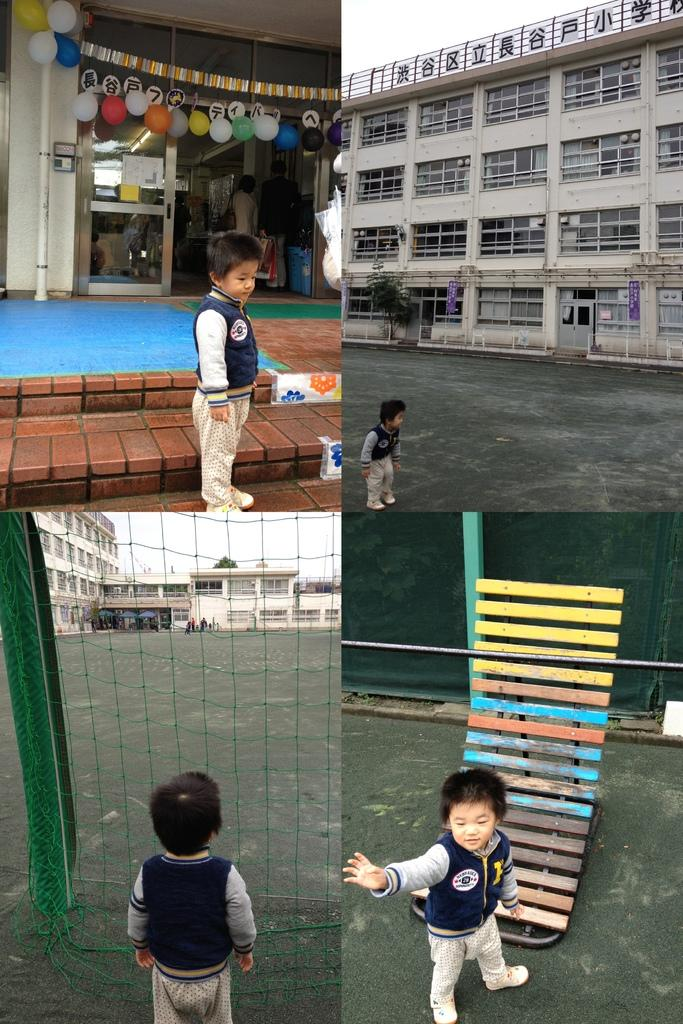What type of artwork is the image? The image is a collage. What types of objects or subjects can be seen in the collage? There are buildings, people, a boy, a green net, balloons, and a road in the collage. Can you describe the boy in the collage? There is a boy in the collage, and he appears to be similar in all the pictures of the collage. What type of test is the boy taking in the collage? There is no test present in the collage; it features a collage of various objects and subjects, including a boy who appears to be similar in all the pictures. 